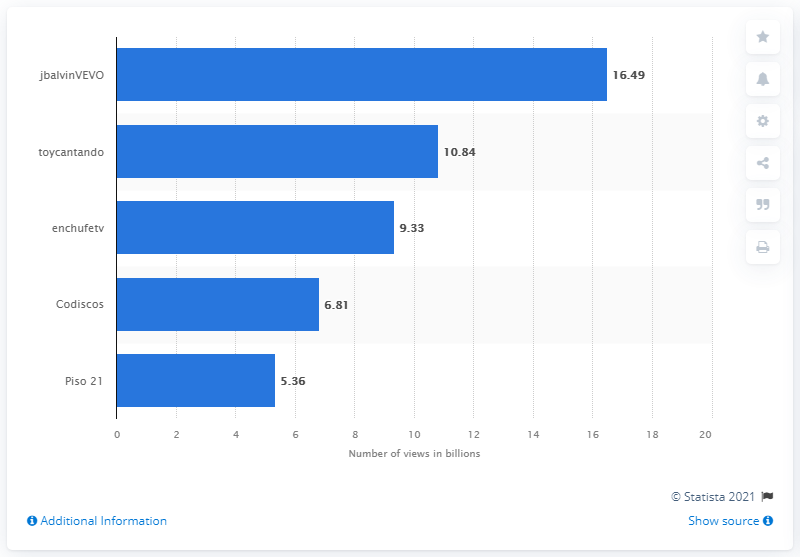Give some essential details in this illustration. As of March 2021, the most viewed YouTube channel in Colombia was jbalvinVEVO. 